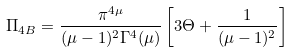Convert formula to latex. <formula><loc_0><loc_0><loc_500><loc_500>\Pi _ { 4 B } = \frac { \pi ^ { 4 \mu } } { ( \mu - 1 ) ^ { 2 } \Gamma ^ { 4 } ( \mu ) } \left [ 3 \Theta + \frac { 1 } { ( \mu - 1 ) ^ { 2 } } \right ]</formula> 